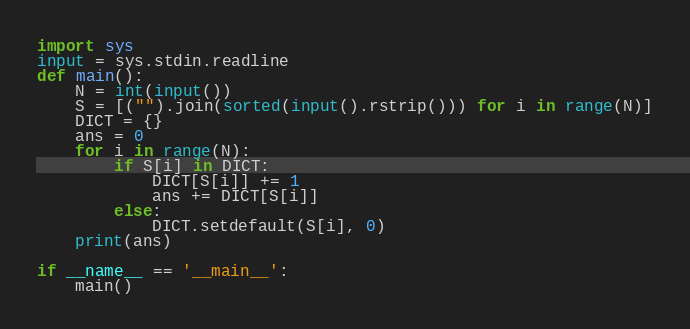Convert code to text. <code><loc_0><loc_0><loc_500><loc_500><_Python_>import sys
input = sys.stdin.readline
def main():
    N = int(input())
    S = [("").join(sorted(input().rstrip())) for i in range(N)]
    DICT = {}
    ans = 0
    for i in range(N):
        if S[i] in DICT:
            DICT[S[i]] += 1
            ans += DICT[S[i]]
        else:
            DICT.setdefault(S[i], 0)
    print(ans)

if __name__ == '__main__':
    main()</code> 